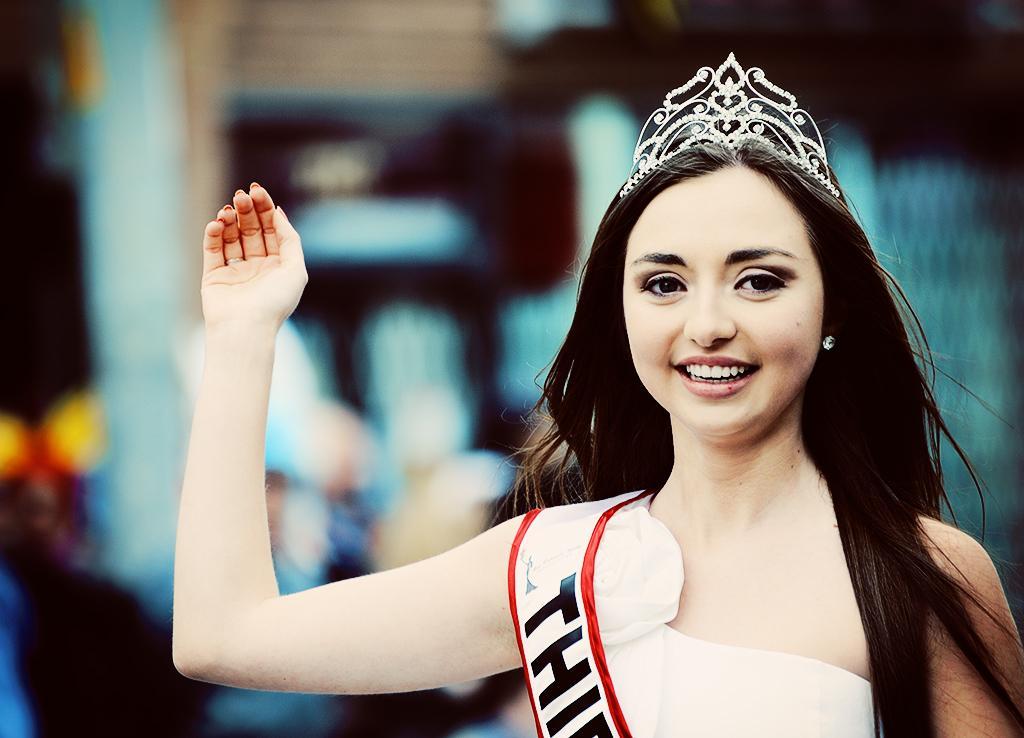How would you summarize this image in a sentence or two? In this image we can see a lady. A lady is wearing a crown on her head. 